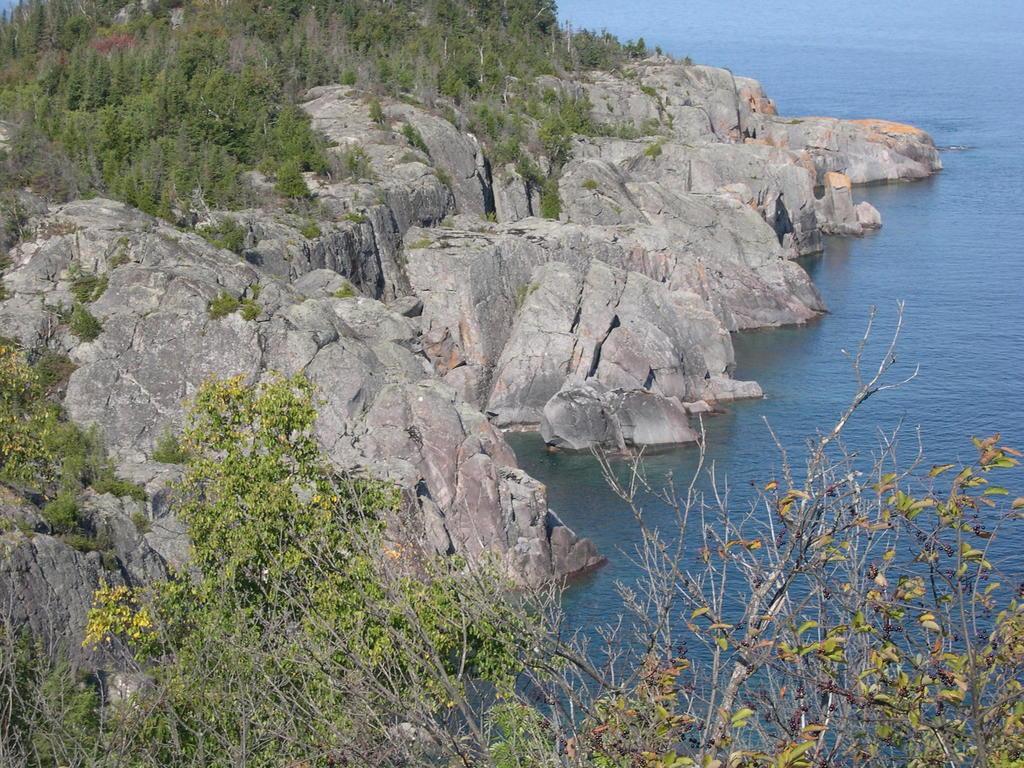Could you give a brief overview of what you see in this image? In this picture we see rocks and trees near a sea with water. 